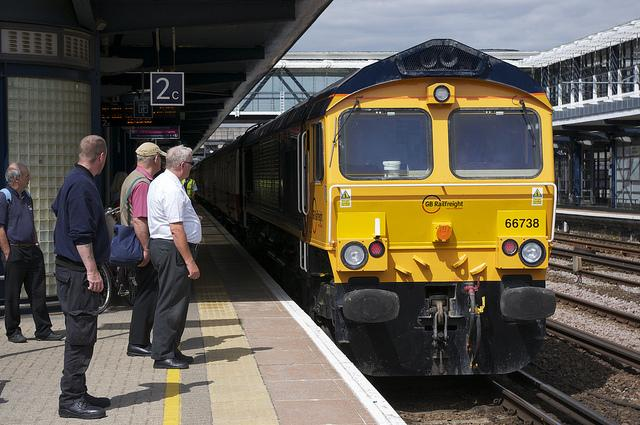Why is there a yellow line on the ground?

Choices:
A) as prank
B) optical illusion
C) decoration
D) safety safety 